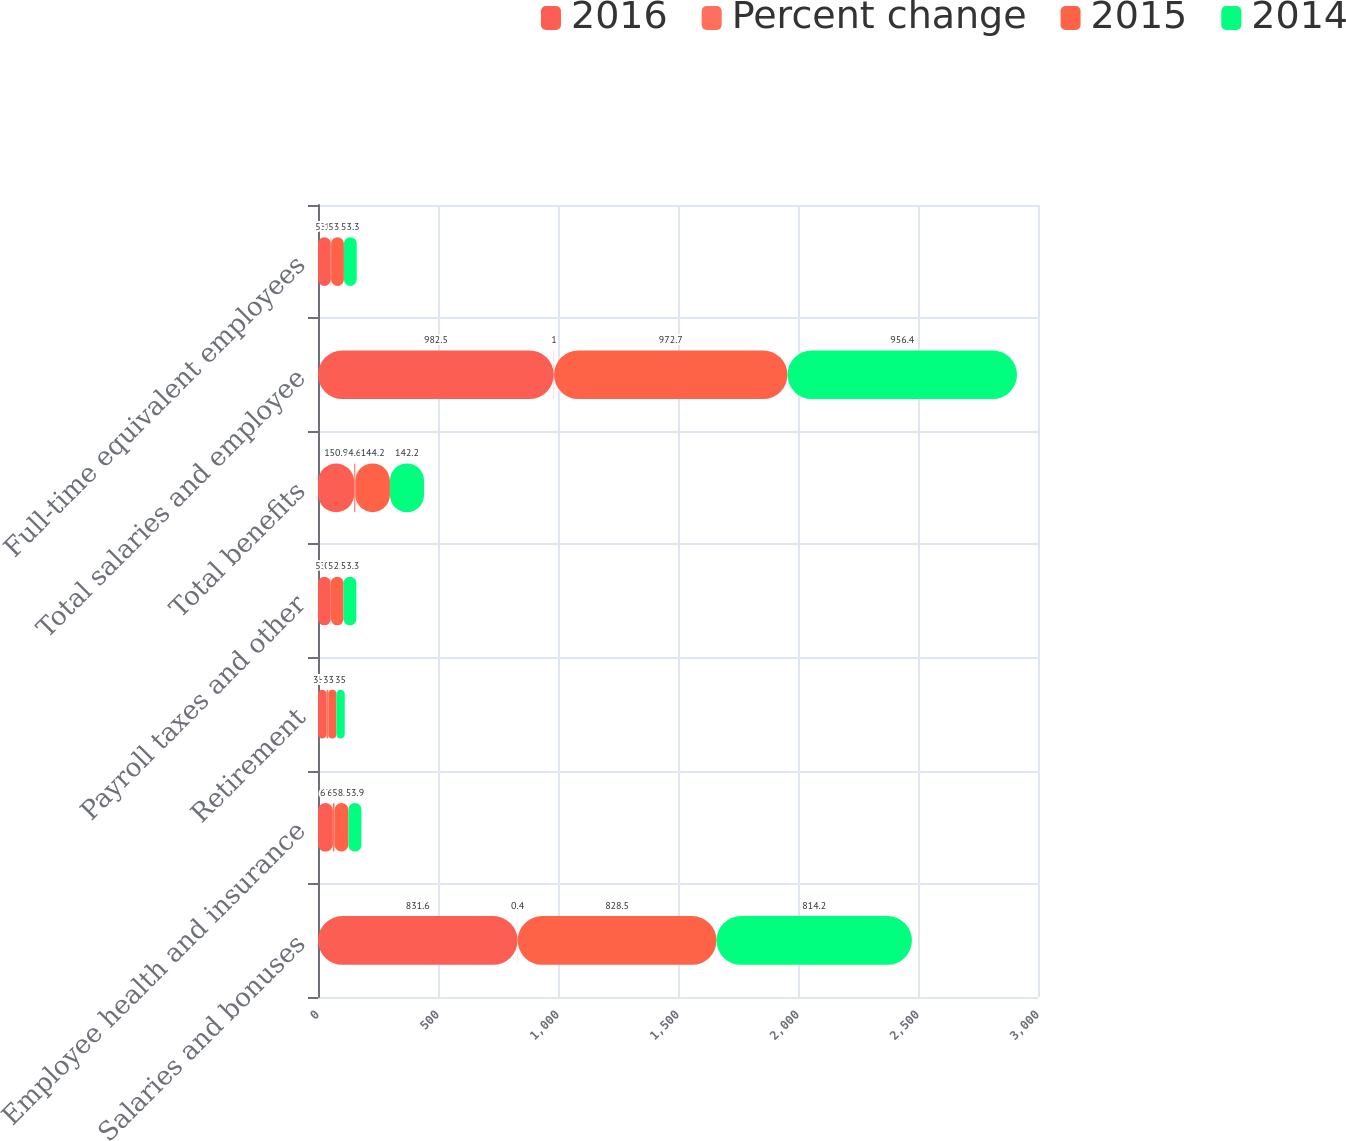Convert chart to OTSL. <chart><loc_0><loc_0><loc_500><loc_500><stacked_bar_chart><ecel><fcel>Salaries and bonuses<fcel>Employee health and insurance<fcel>Retirement<fcel>Payroll taxes and other<fcel>Total benefits<fcel>Total salaries and employee<fcel>Full-time equivalent employees<nl><fcel>2016<fcel>831.6<fcel>62<fcel>35.8<fcel>53.1<fcel>150.9<fcel>982.5<fcel>53.3<nl><fcel>Percent change<fcel>0.4<fcel>6.7<fcel>7.2<fcel>0.8<fcel>4.6<fcel>1<fcel>1.4<nl><fcel>2015<fcel>828.5<fcel>58.1<fcel>33.4<fcel>52.7<fcel>144.2<fcel>972.7<fcel>53.3<nl><fcel>2014<fcel>814.2<fcel>53.9<fcel>35<fcel>53.3<fcel>142.2<fcel>956.4<fcel>53.3<nl></chart> 